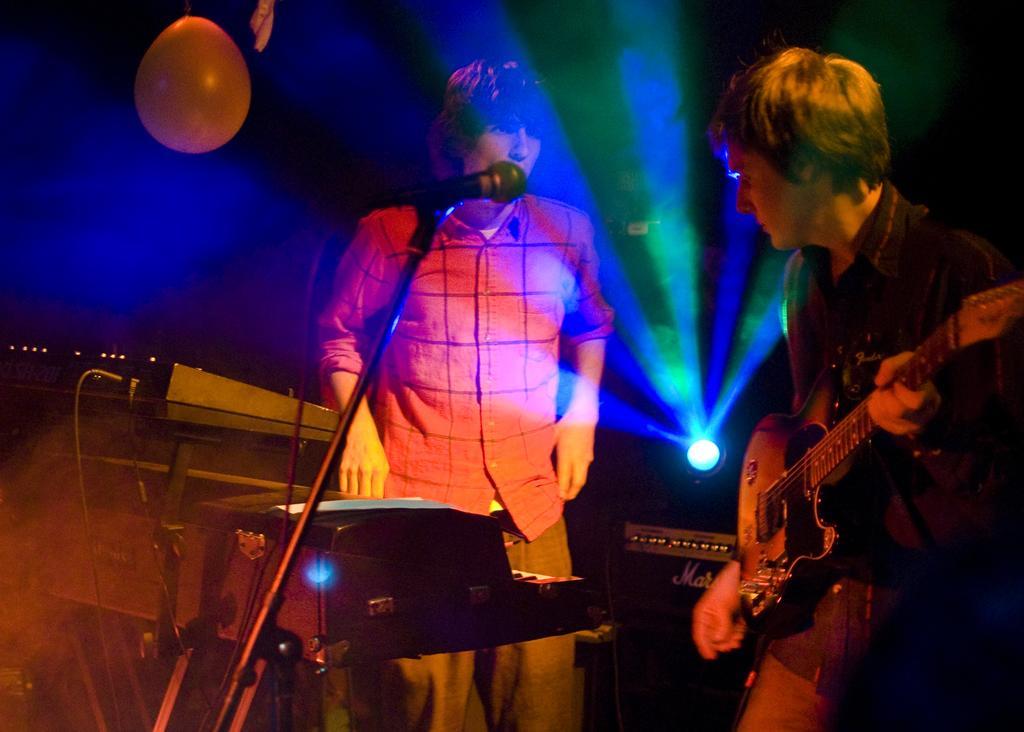How would you summarize this image in a sentence or two? In this picture there is a boy who is standing on the right side of the image, by holding a guitar in his hands and there is another boy in the center of the image and there is a piano and a mic in front of him, there is a balloon at the top side of the image and there is a spotlight in the background area of the image. 